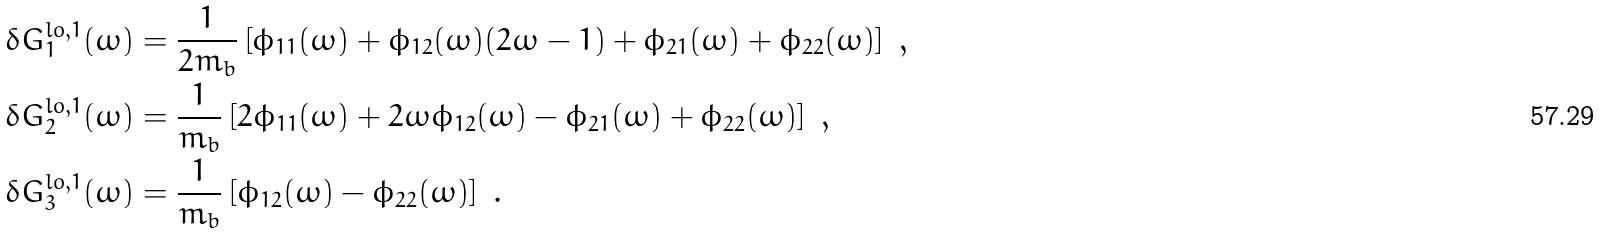Convert formula to latex. <formula><loc_0><loc_0><loc_500><loc_500>\delta G _ { 1 } ^ { l o , 1 } ( \omega ) & = \frac { 1 } { 2 m _ { b } } \left [ \phi _ { 1 1 } ( \omega ) + \phi _ { 1 2 } ( \omega ) ( 2 \omega - 1 ) + \phi _ { 2 1 } ( \omega ) + \phi _ { 2 2 } ( \omega ) \right ] \ , \\ \delta G _ { 2 } ^ { l o , 1 } ( \omega ) & = \frac { 1 } { m _ { b } } \left [ 2 \phi _ { 1 1 } ( \omega ) + 2 \omega \phi _ { 1 2 } ( \omega ) - \phi _ { 2 1 } ( \omega ) + \phi _ { 2 2 } ( \omega ) \right ] \ , \\ \delta G _ { 3 } ^ { l o , 1 } ( \omega ) & = \frac { 1 } { m _ { b } } \left [ \phi _ { 1 2 } ( \omega ) - \phi _ { 2 2 } ( \omega ) \right ] \ .</formula> 